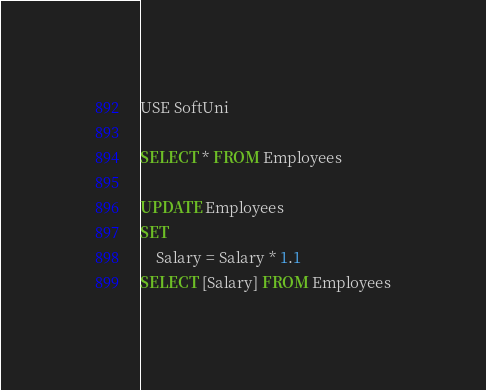Convert code to text. <code><loc_0><loc_0><loc_500><loc_500><_SQL_>USE SoftUni

SELECT * FROM Employees

UPDATE Employees
SET
	Salary = Salary * 1.1
SELECT [Salary] FROM Employees</code> 